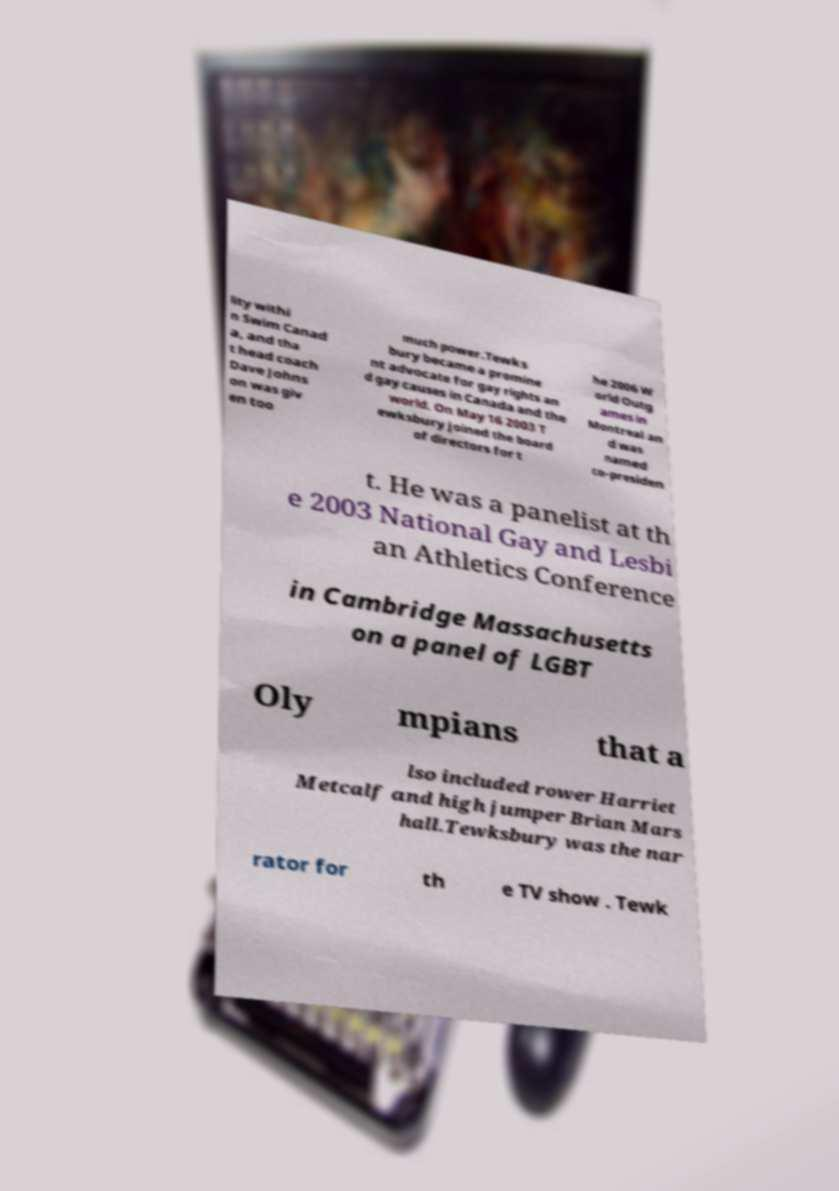Please read and relay the text visible in this image. What does it say? lity withi n Swim Canad a, and tha t head coach Dave Johns on was giv en too much power.Tewks bury became a promine nt advocate for gay rights an d gay causes in Canada and the world. On May 16 2003 T ewksbury joined the board of directors for t he 2006 W orld Outg ames in Montreal an d was named co-presiden t. He was a panelist at th e 2003 National Gay and Lesbi an Athletics Conference in Cambridge Massachusetts on a panel of LGBT Oly mpians that a lso included rower Harriet Metcalf and high jumper Brian Mars hall.Tewksbury was the nar rator for th e TV show . Tewk 